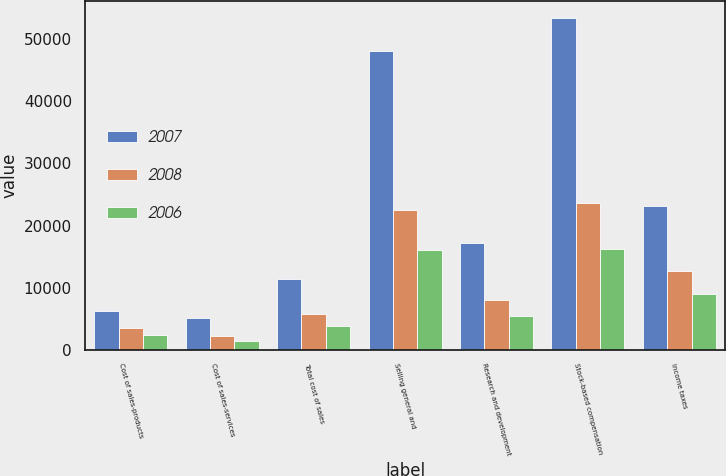Convert chart. <chart><loc_0><loc_0><loc_500><loc_500><stacked_bar_chart><ecel><fcel>Cost of sales-products<fcel>Cost of sales-services<fcel>Total cost of sales<fcel>Selling general and<fcel>Research and development<fcel>Stock-based compensation<fcel>Income taxes<nl><fcel>2007<fcel>6311<fcel>5077<fcel>11388<fcel>48149<fcel>17109<fcel>53441<fcel>23205<nl><fcel>2008<fcel>3472<fcel>2276<fcel>5748<fcel>22560<fcel>7984<fcel>23641<fcel>12651<nl><fcel>2006<fcel>2417<fcel>1452<fcel>3869<fcel>16037<fcel>5354<fcel>16298<fcel>8962<nl></chart> 